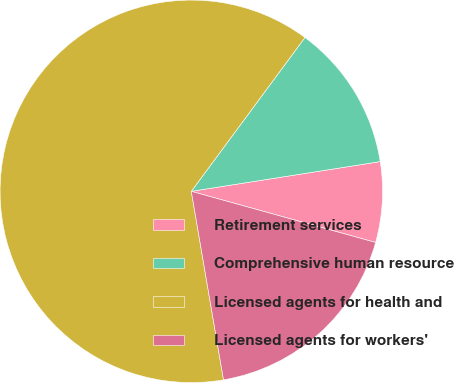Convert chart to OTSL. <chart><loc_0><loc_0><loc_500><loc_500><pie_chart><fcel>Retirement services<fcel>Comprehensive human resource<fcel>Licensed agents for health and<fcel>Licensed agents for workers'<nl><fcel>6.79%<fcel>12.39%<fcel>62.82%<fcel>18.0%<nl></chart> 